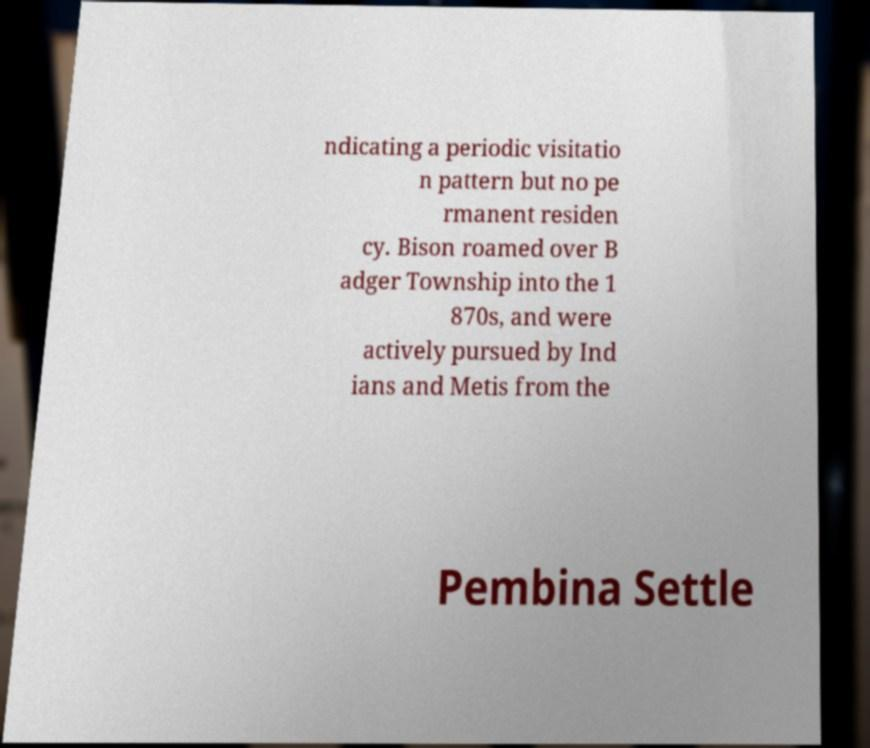Could you extract and type out the text from this image? ndicating a periodic visitatio n pattern but no pe rmanent residen cy. Bison roamed over B adger Township into the 1 870s, and were actively pursued by Ind ians and Metis from the Pembina Settle 